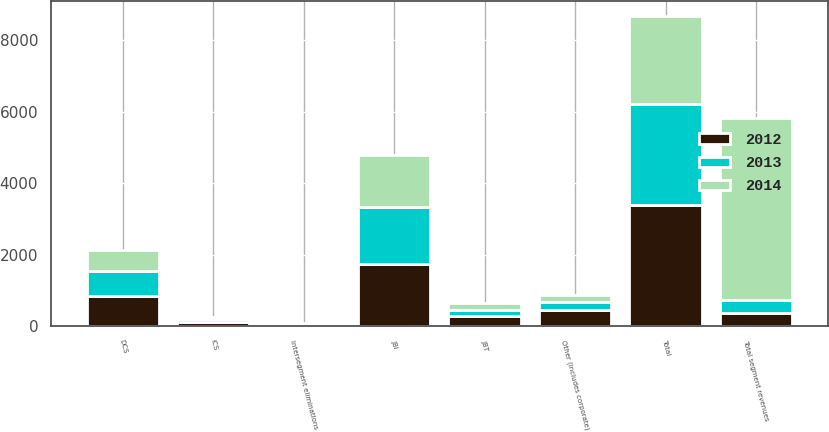<chart> <loc_0><loc_0><loc_500><loc_500><stacked_bar_chart><ecel><fcel>JBI<fcel>DCS<fcel>ICS<fcel>JBT<fcel>Other (includes corporate)<fcel>Total<fcel>Total segment revenues<fcel>Intersegment eliminations<nl><fcel>2012<fcel>1733<fcel>832<fcel>106<fcel>289<fcel>437<fcel>3397<fcel>363<fcel>20<nl><fcel>2013<fcel>1611<fcel>721<fcel>78<fcel>164<fcel>245<fcel>2819<fcel>363<fcel>30<nl><fcel>2014<fcel>1443<fcel>586<fcel>55<fcel>185<fcel>196<fcel>2465<fcel>5091<fcel>36<nl></chart> 